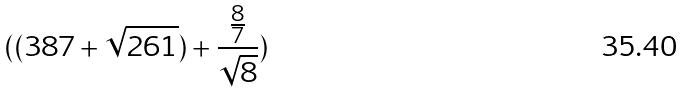Convert formula to latex. <formula><loc_0><loc_0><loc_500><loc_500>( ( 3 8 7 + \sqrt { 2 6 1 } ) + \frac { \frac { 8 } { 7 } } { \sqrt { 8 } } )</formula> 